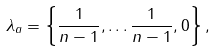Convert formula to latex. <formula><loc_0><loc_0><loc_500><loc_500>\lambda _ { a } = \left \{ \frac { 1 } { n - 1 } , \dots \frac { 1 } { n - 1 } , 0 \right \} ,</formula> 